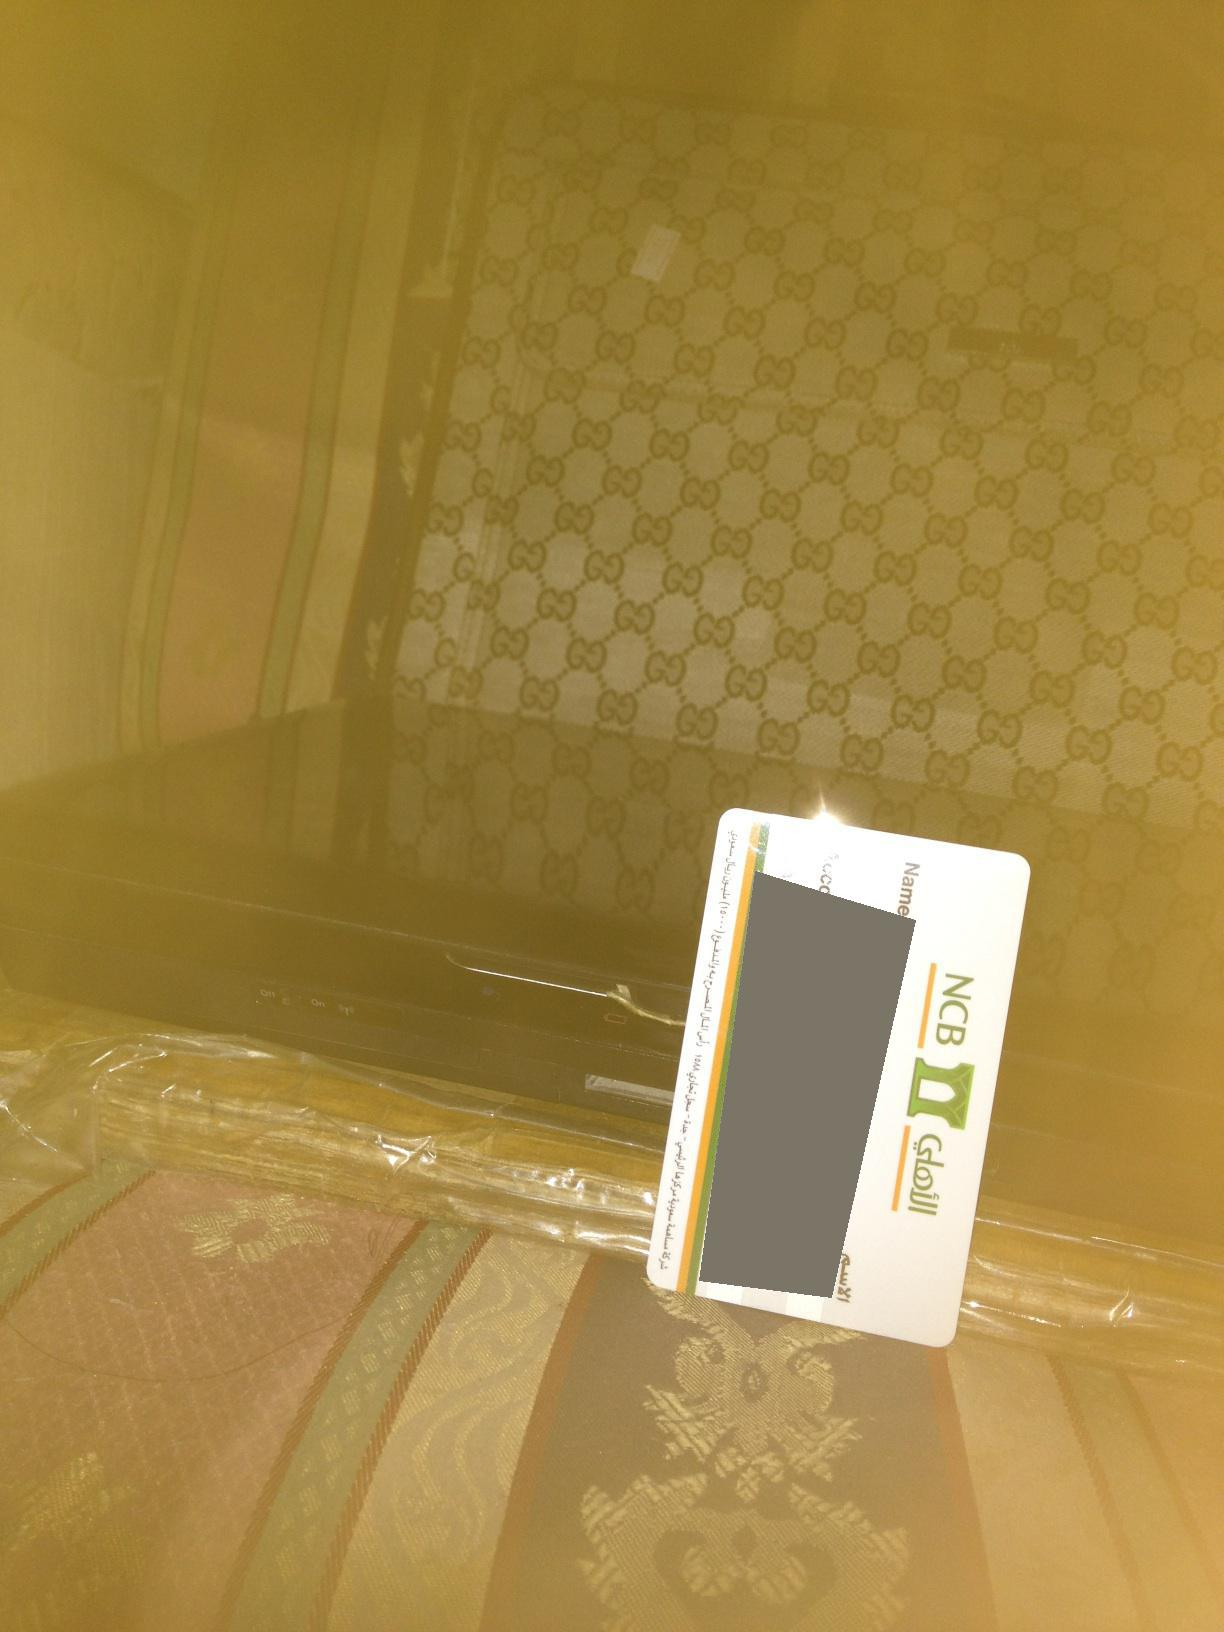Create a fictional scenario involving this image where the suitcase has a mysterious content. In a dimly lit room, the golden hue casts an almost otherworldly glow on the scene. On an ornate couch lies a suitcase with an intricate logo, a symbol of exclusivity and secrecy. Beside it, a recently used credit card rests, hinting at recent significant transactions. The suitcase, however, is no ordinary piece of luggage. Within it lies an ancient artifact, said to possess powers beyond human comprehension, sought after by historians and secret organizations alike. The individual who placed it there, now hastily packing to switch locations, is on the run. The electronic device beneath is a complex piece of technology, a scanner designed to decipher the cryptic inscriptions on the artifact. This seemingly calm setting is the center stage of a thrilling chase involving high stakes and profound mysteries. 